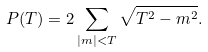<formula> <loc_0><loc_0><loc_500><loc_500>P ( T ) = 2 \sum _ { | m | < T } \sqrt { T ^ { 2 } - m ^ { 2 } } .</formula> 